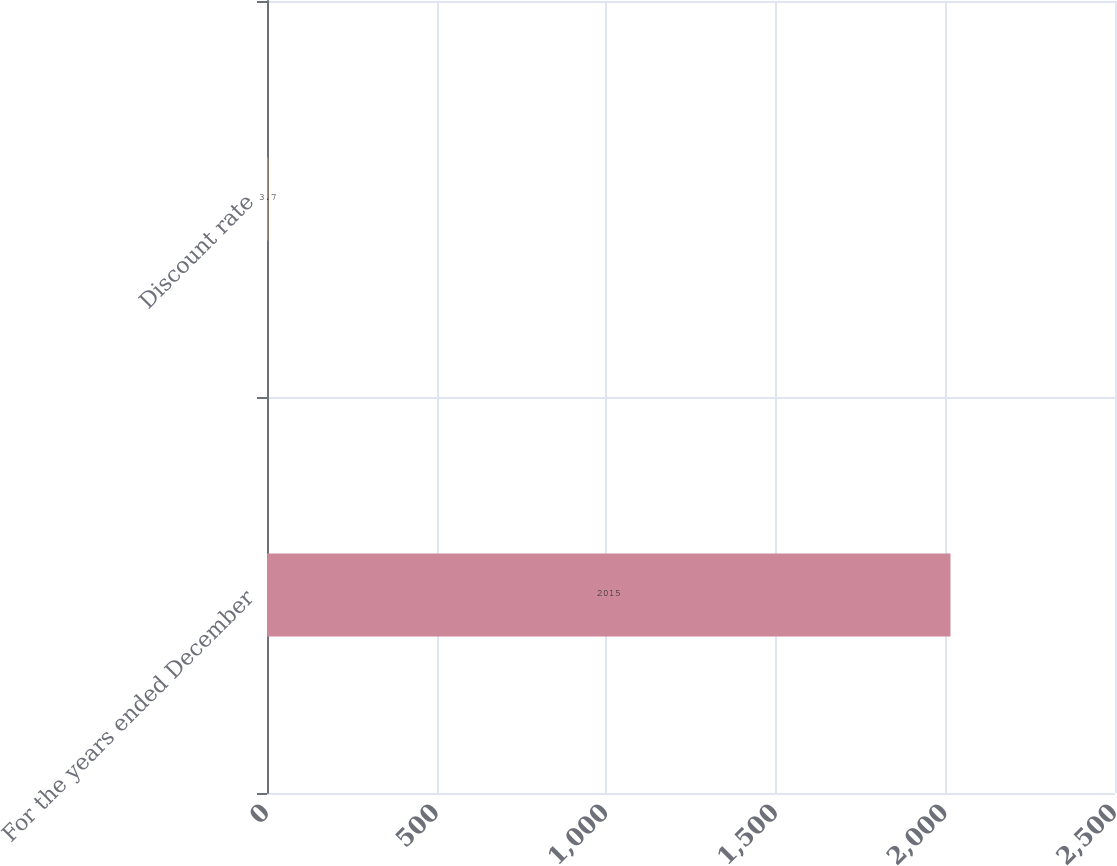Convert chart. <chart><loc_0><loc_0><loc_500><loc_500><bar_chart><fcel>For the years ended December<fcel>Discount rate<nl><fcel>2015<fcel>3.7<nl></chart> 